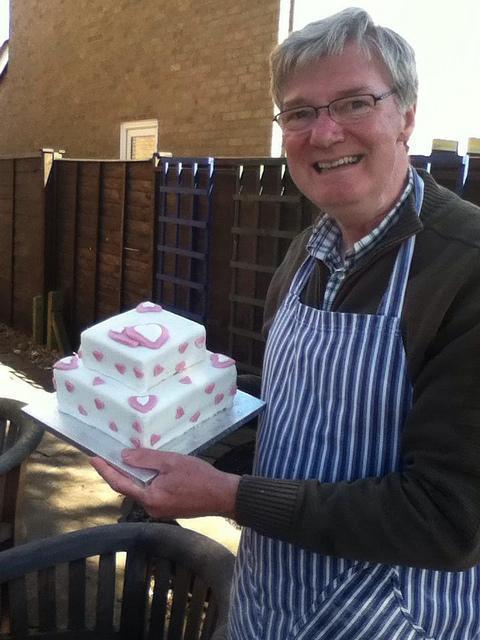How many tiers on the cake?
Give a very brief answer. 2. How many chairs are there?
Give a very brief answer. 2. How many bananas are in the picture?
Give a very brief answer. 0. 